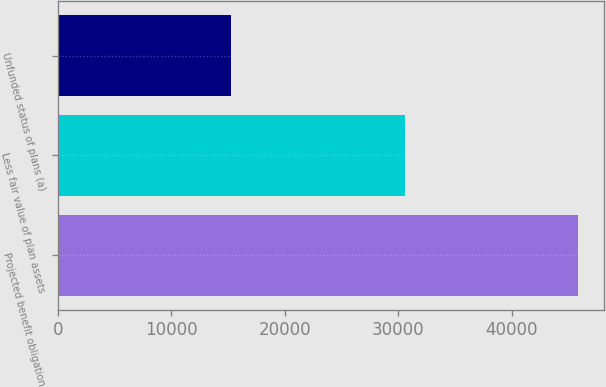Convert chart. <chart><loc_0><loc_0><loc_500><loc_500><bar_chart><fcel>Projected benefit obligation<fcel>Less fair value of plan assets<fcel>Unfunded status of plans (a)<nl><fcel>45875<fcel>30597<fcel>15278<nl></chart> 